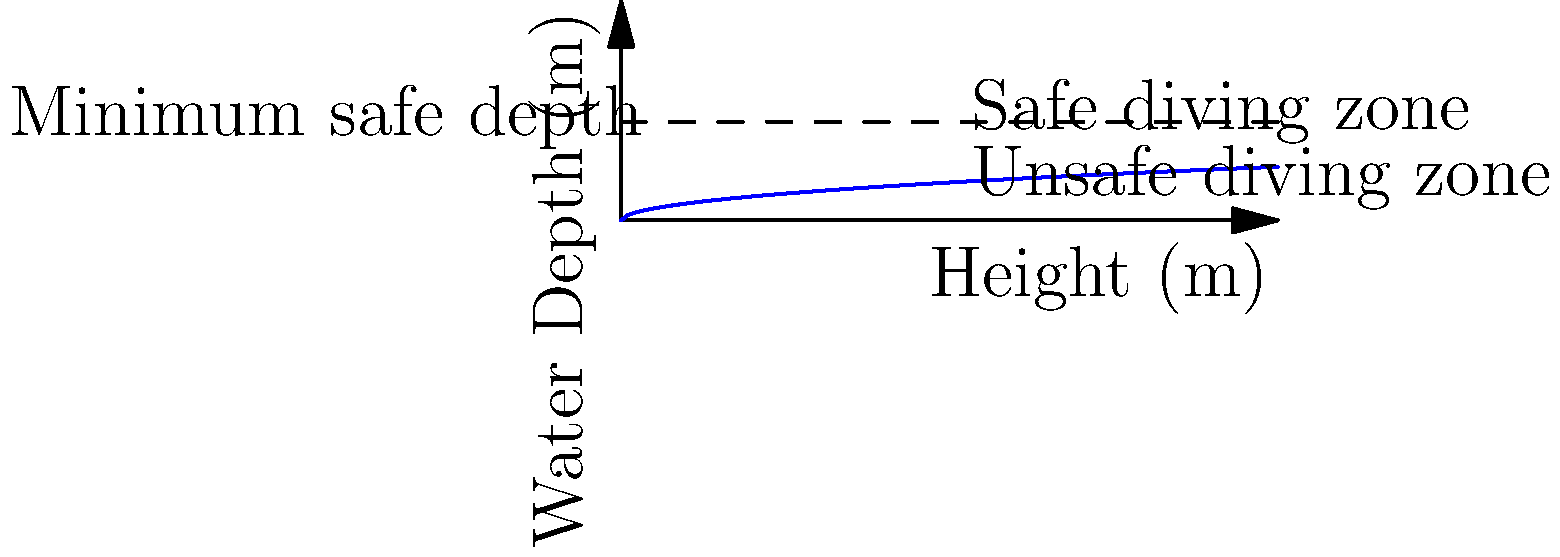A diving platform is being constructed at a height of 20 meters. Using the graph, which shows the relationship between dive height and minimum safe water depth, estimate the minimum water depth required for safe diving from this platform. To solve this problem, we need to follow these steps:

1. Locate the dive height of 20 meters on the x-axis of the graph.
2. From this point, move vertically up until we intersect the blue curve, which represents the relationship between dive height and minimum safe water depth.
3. From the intersection point, move horizontally to the y-axis to read the corresponding minimum safe water depth.

Looking at the graph, we can see that for a dive height of 20 meters:

1. The vertical line from 20 meters on the x-axis intersects the blue curve at approximately the 6 meters mark on the y-axis.
2. The equation of the curve appears to be $y = \sqrt{\frac{x}{5}}$, where $y$ is the water depth and $x$ is the dive height.
3. We can verify this by calculating: $\sqrt{\frac{20}{5}} = \sqrt{4} = 2$

Therefore, the minimum safe water depth for a 20-meter dive is approximately 6 meters.
Answer: 6 meters 